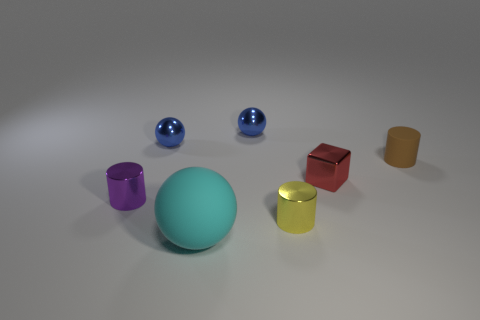Are there more cyan things than small cyan metal blocks?
Keep it short and to the point. Yes. What size is the yellow cylinder that is made of the same material as the red cube?
Your answer should be very brief. Small. There is a cylinder that is behind the small red metallic object; is it the same size as the metallic object that is in front of the tiny purple metallic cylinder?
Your answer should be compact. Yes. How many things are small things that are on the right side of the yellow object or tiny matte objects?
Keep it short and to the point. 2. Is the number of cylinders less than the number of brown matte objects?
Offer a terse response. No. The tiny object in front of the shiny cylinder that is to the left of the rubber thing that is on the left side of the tiny red shiny block is what shape?
Make the answer very short. Cylinder. Is there a tiny yellow thing?
Offer a terse response. Yes. There is a red metal thing; does it have the same size as the cylinder that is on the right side of the small block?
Offer a very short reply. Yes. Is there a blue sphere to the right of the sphere that is in front of the brown matte cylinder?
Your response must be concise. Yes. There is a thing that is both in front of the tiny purple metal object and on the left side of the yellow metallic object; what material is it?
Ensure brevity in your answer.  Rubber. 